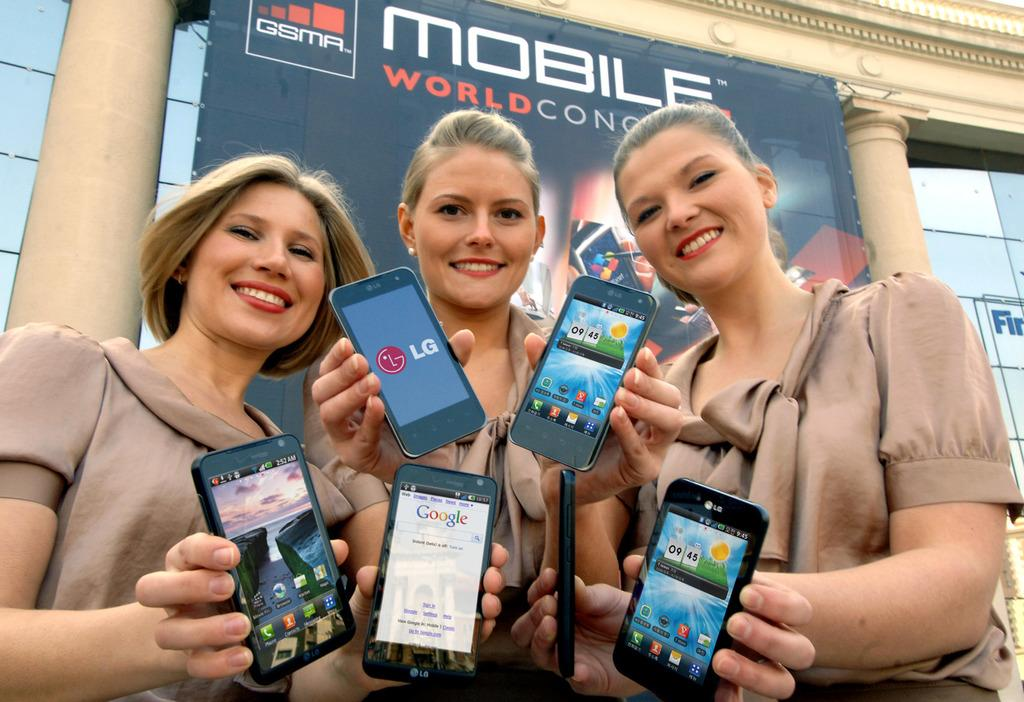<image>
Offer a succinct explanation of the picture presented. Three blonds in front of a sign that says Mobile world con. 